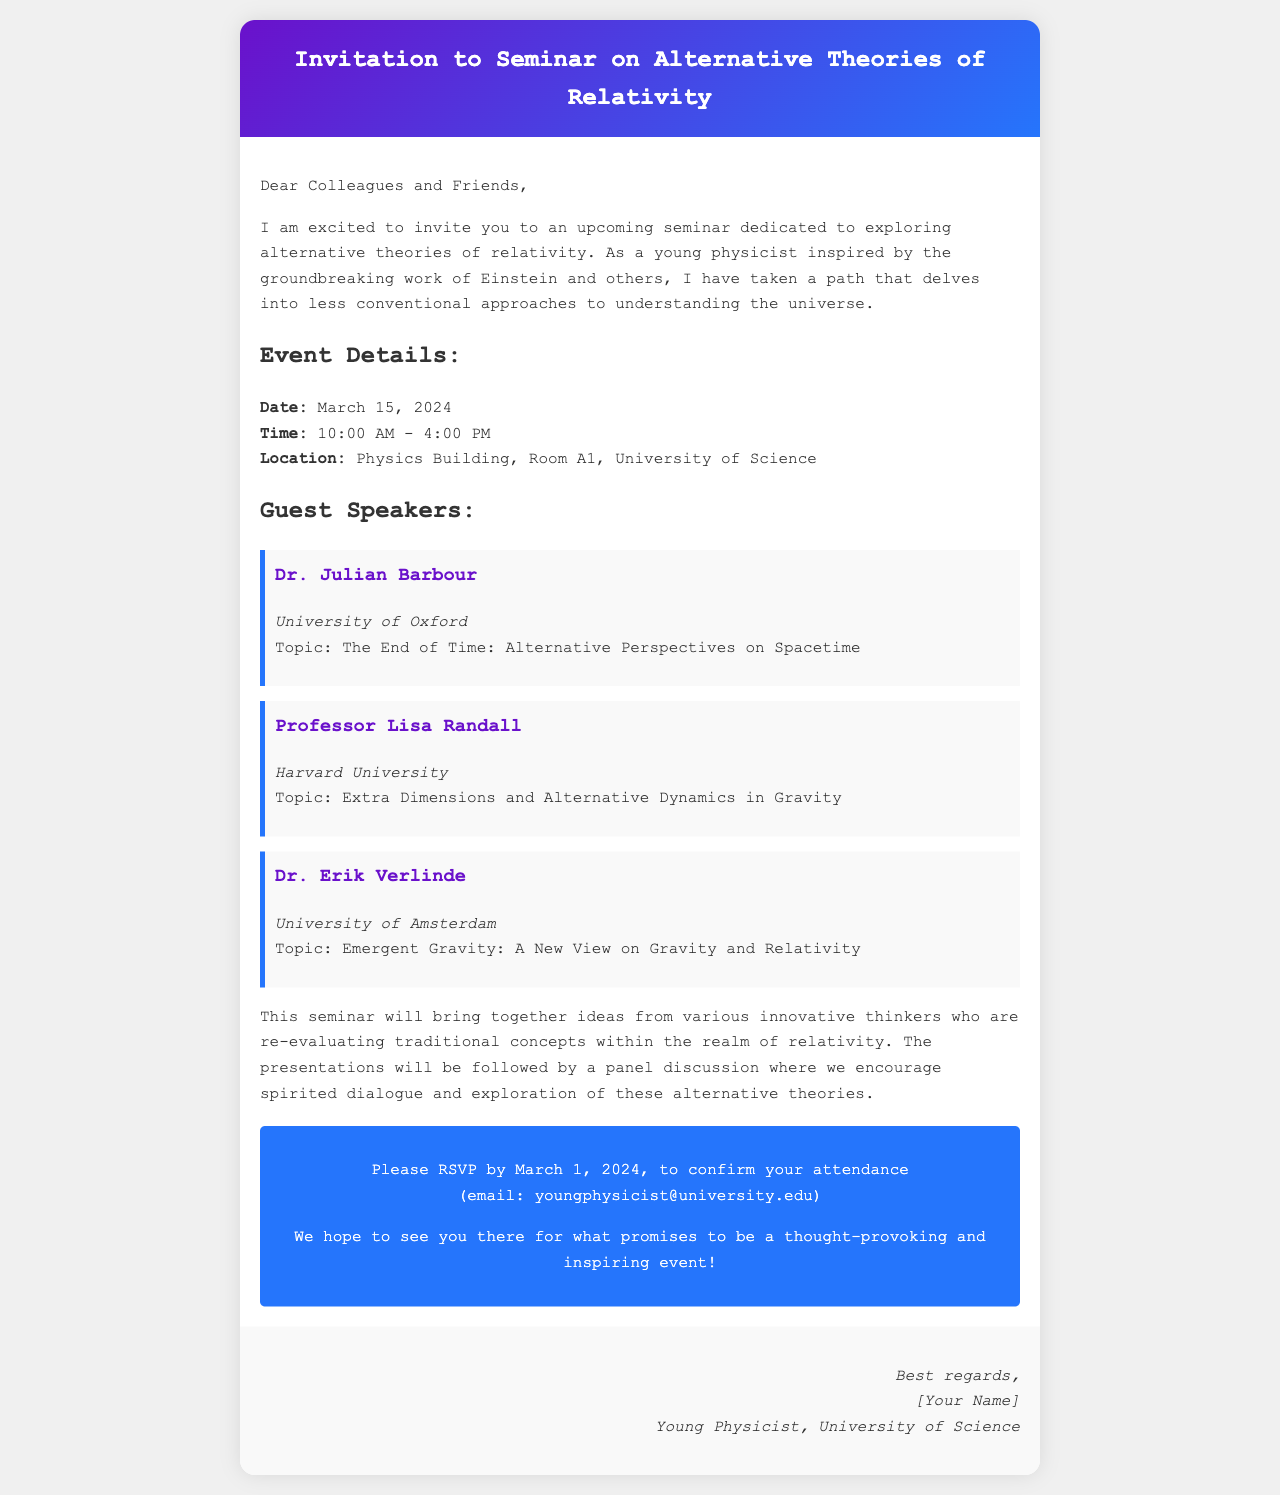What is the date of the seminar? The date of the seminar is explicitly stated in the document under "Event Details".
Answer: March 15, 2024 Who is one of the guest speakers? The document lists three guest speakers; each is introduced under the "Guest Speakers" section.
Answer: Dr. Julian Barbour What is the topic of Dr. Erik Verlinde's presentation? The specific topic is mentioned directly after Dr. Erik Verlinde's name in the speaker section of the document.
Answer: Emergent Gravity: A New View on Gravity and Relativity What is the time range for the seminar? The time range is provided under "Event Details", giving the beginning and ending time of the seminar.
Answer: 10:00 AM - 4:00 PM By what date should attendees RSVP? The RSVP date is mentioned clearly in the call to action section of the document.
Answer: March 1, 2024 What is the main theme of the seminar? The invitation mentions that the seminar explores “alternative theories of relativity” as its central theme.
Answer: Alternative theories of relativity Which university is Dr. Julian Barbour affiliated with? The document provides the university affiliation of each speaker directly after their names.
Answer: University of Oxford Where is the seminar being held? The location of the seminar is described in the "Event Details" section of the document.
Answer: Physics Building, Room A1, University of Science 